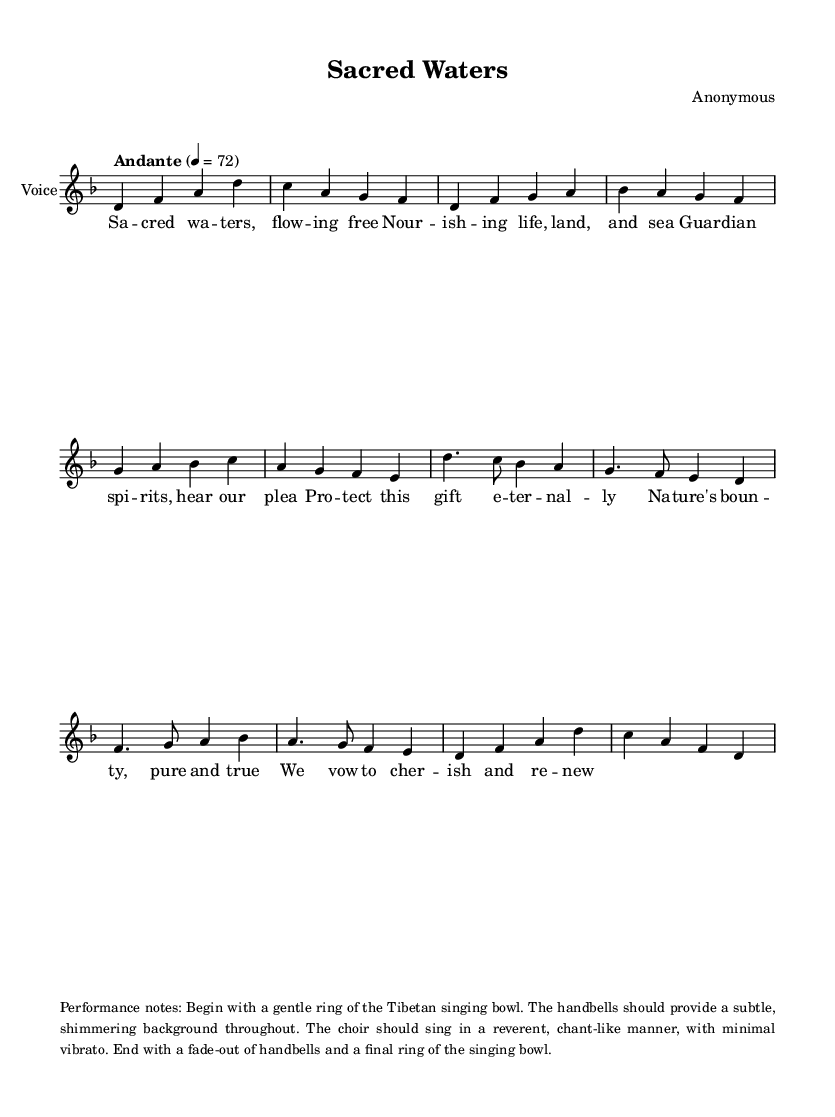What is the key signature of this music? The key signature is identified at the beginning of the staff. Here, there is one flat, indicating D minor.
Answer: D minor What is the time signature of this music? The time signature is found next to the clef at the beginning of the music. It shows 4/4, meaning there are four beats in each measure.
Answer: 4/4 What is the tempo indicated for this piece? The tempo marking provided at the start of the sheet music indicates the speed of the piece. Here, it is marked as "Andante" at 4 = 72.
Answer: Andante How many verses are included in the lyrics? The lyrics section has a specific structure generally repeated throughout. In this case, there is one verse presented in the lyrics.
Answer: One What is the primary theme expressed in the lyrics? The lyrics emphasize the protection and sanctity of nature and natural resources, as expressed through the words and their meaning. The overall focus is on cherishing nature.
Answer: Protection of nature What performance notes are indicated for this chant? The performance notes at the bottom of the sheet music give specific instructions for performing the piece. They detail the use of a Tibetan singing bowl and handbells, creating a serene atmosphere.
Answer: Use of Tibetan singing bowl and handbells 